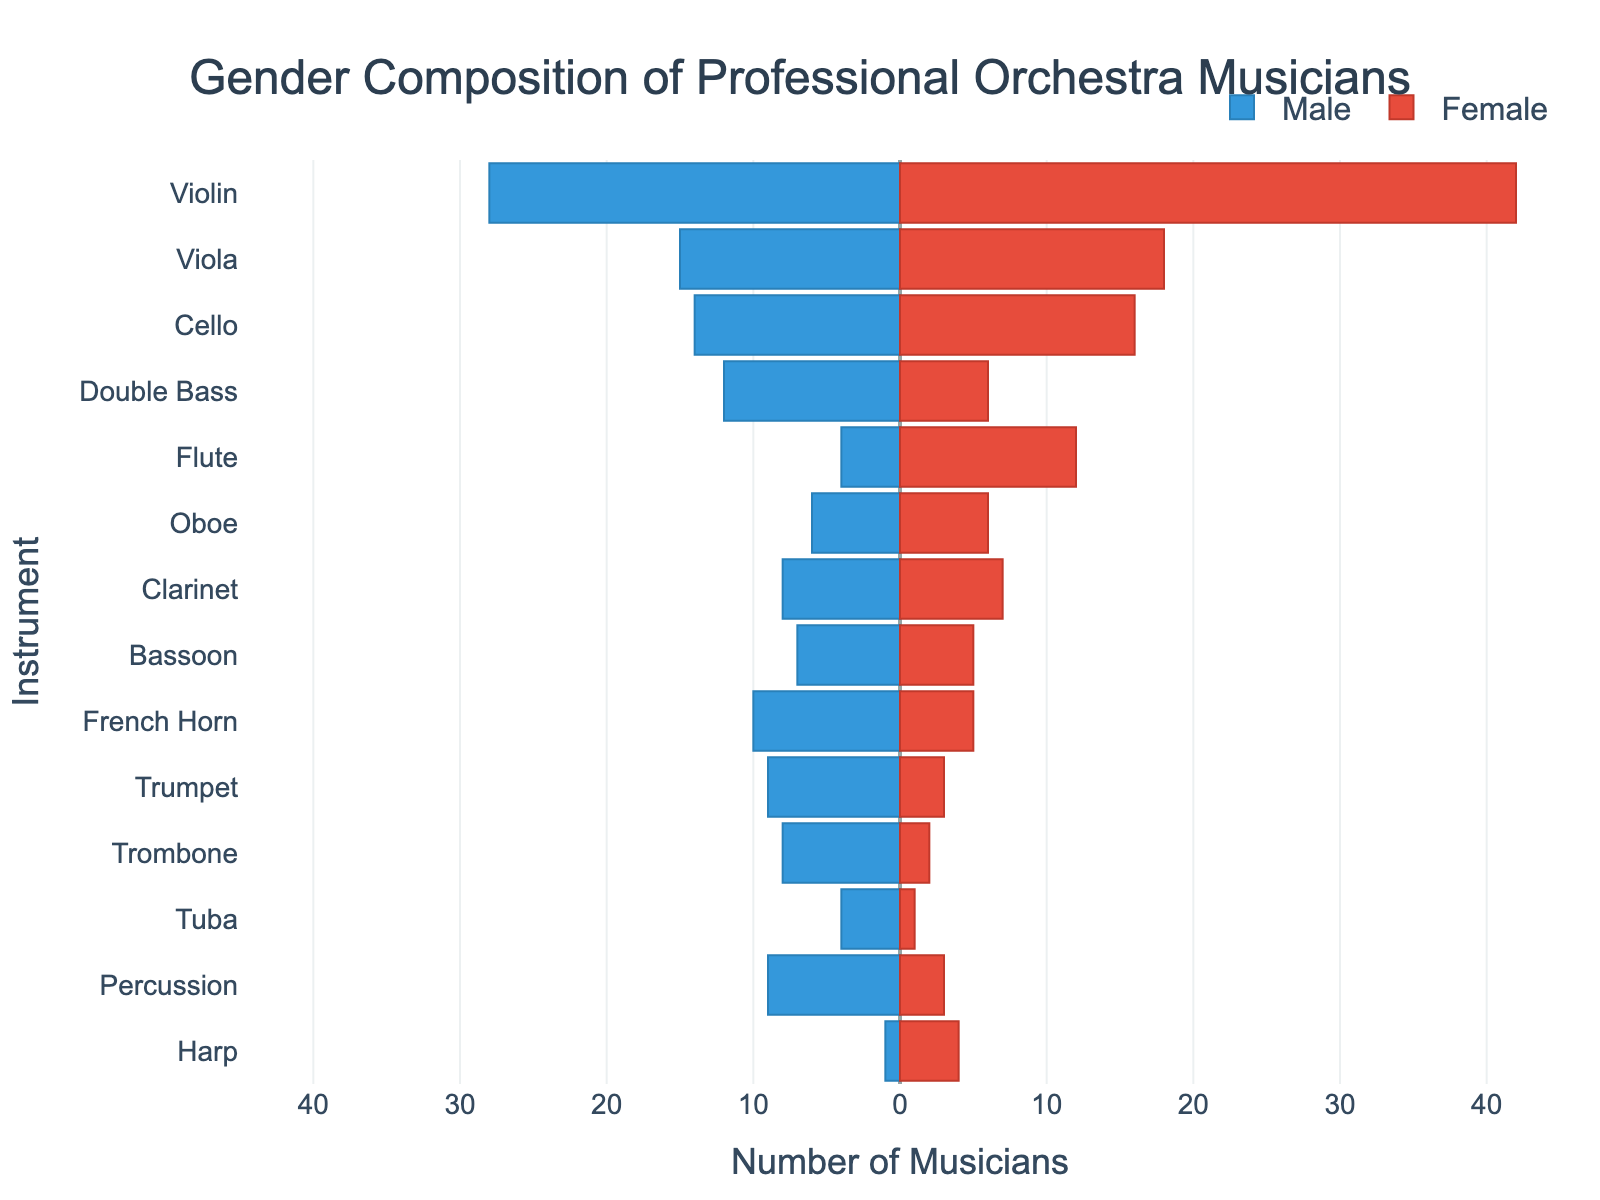What's the title of the figure? The title of the figure is located at the top center of the plot. Based on the information provided, the title reads: "Gender Composition of Professional Orchestra Musicians".
Answer: Gender Composition of Professional Orchestra Musicians What instrument has the highest number of female musicians? To find the instrument with the highest number of female musicians, look for the longest red bar (representing females) in the plot. The violin section has the longest red bar, indicating the highest number of female musicians.
Answer: Violin What is the difference in the number of male and female musicians in the Double Bass section? Locate the Double Bass section on the y-axis. The number of male musicians is 12 (since male values are negative, check the magnitude), and the number of female musicians is 6. Subtract the female number from the male number (12 - 6) to get the difference.
Answer: 6 Which instrument section has an equal number of male and female musicians? Look for instrument sections where the lengths of the male and female bars are the same. The Oboe section has equal lengths for both male and female musicians.
Answer: Oboe Which instrument has the fewest male musicians? Find the shortest bar on the left (blue bars representing males). The Harp section has the shortest blue bar with only 1 male musician.
Answer: Harp What is the combined total number of male and female violinists? For the Violin section, the number of male musicians is 28 and the number of female musicians is 42. Add these numbers together (28 + 42) to get the total.
Answer: 70 How many more female than male musicians are there in the Flute section? Locate the Flute section. The number of female musicians is 12, and the number of male musicians is 4. Subtract the number of male musicians from the number of female musicians (12 - 4) to get the difference.
Answer: 8 Which section has more male musicians: Percussion or Trumpet? Compare the lengths of the blue bars for Percussion and Trumpet. Percussion has 9 male musicians, while Trumpet has 9 male musicians. Therefore, the section with more male musicians between the two is Percussion.
Answer: Percussion What is the total number of musicians in the Oboe section? For the Oboe section, the number of male musicians is 6 and the number of female musicians is also 6. Add these numbers together (6 + 6) to get the total.
Answer: 12 Which instrument has the smallest total number of musicians? To find the instrument with the smallest total number of musicians, combine the counts for male and female musicians for each instrument and identify the smallest sum. The Tuba section has 4 male and 1 female musician (4 + 1 = 5), which is the smallest total number among all sections.
Answer: Tuba 